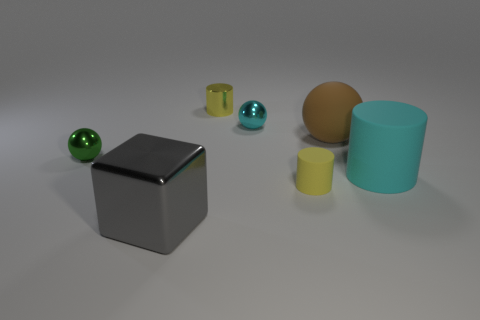Are there more cyan things that are behind the big cyan cylinder than big cylinders behind the large brown sphere?
Provide a short and direct response. Yes. How many other objects are the same size as the brown rubber thing?
Ensure brevity in your answer.  2. Is the material of the tiny object to the left of the gray shiny block the same as the big cyan object?
Ensure brevity in your answer.  No. What number of other objects are the same color as the small metallic cylinder?
Your response must be concise. 1. How many other objects are there of the same shape as the small cyan metallic object?
Your response must be concise. 2. There is a object to the left of the big gray block; is its shape the same as the cyan rubber thing behind the big metal cube?
Ensure brevity in your answer.  No. Are there an equal number of balls to the left of the tiny yellow matte object and tiny yellow shiny things that are right of the brown matte ball?
Provide a short and direct response. No. What shape is the metal object that is in front of the yellow cylinder that is in front of the yellow object to the left of the cyan metallic ball?
Provide a succinct answer. Cube. Is the small cylinder in front of the big cyan rubber thing made of the same material as the tiny yellow thing behind the big brown object?
Make the answer very short. No. What is the shape of the tiny metallic object that is behind the tiny cyan metallic object?
Give a very brief answer. Cylinder. 